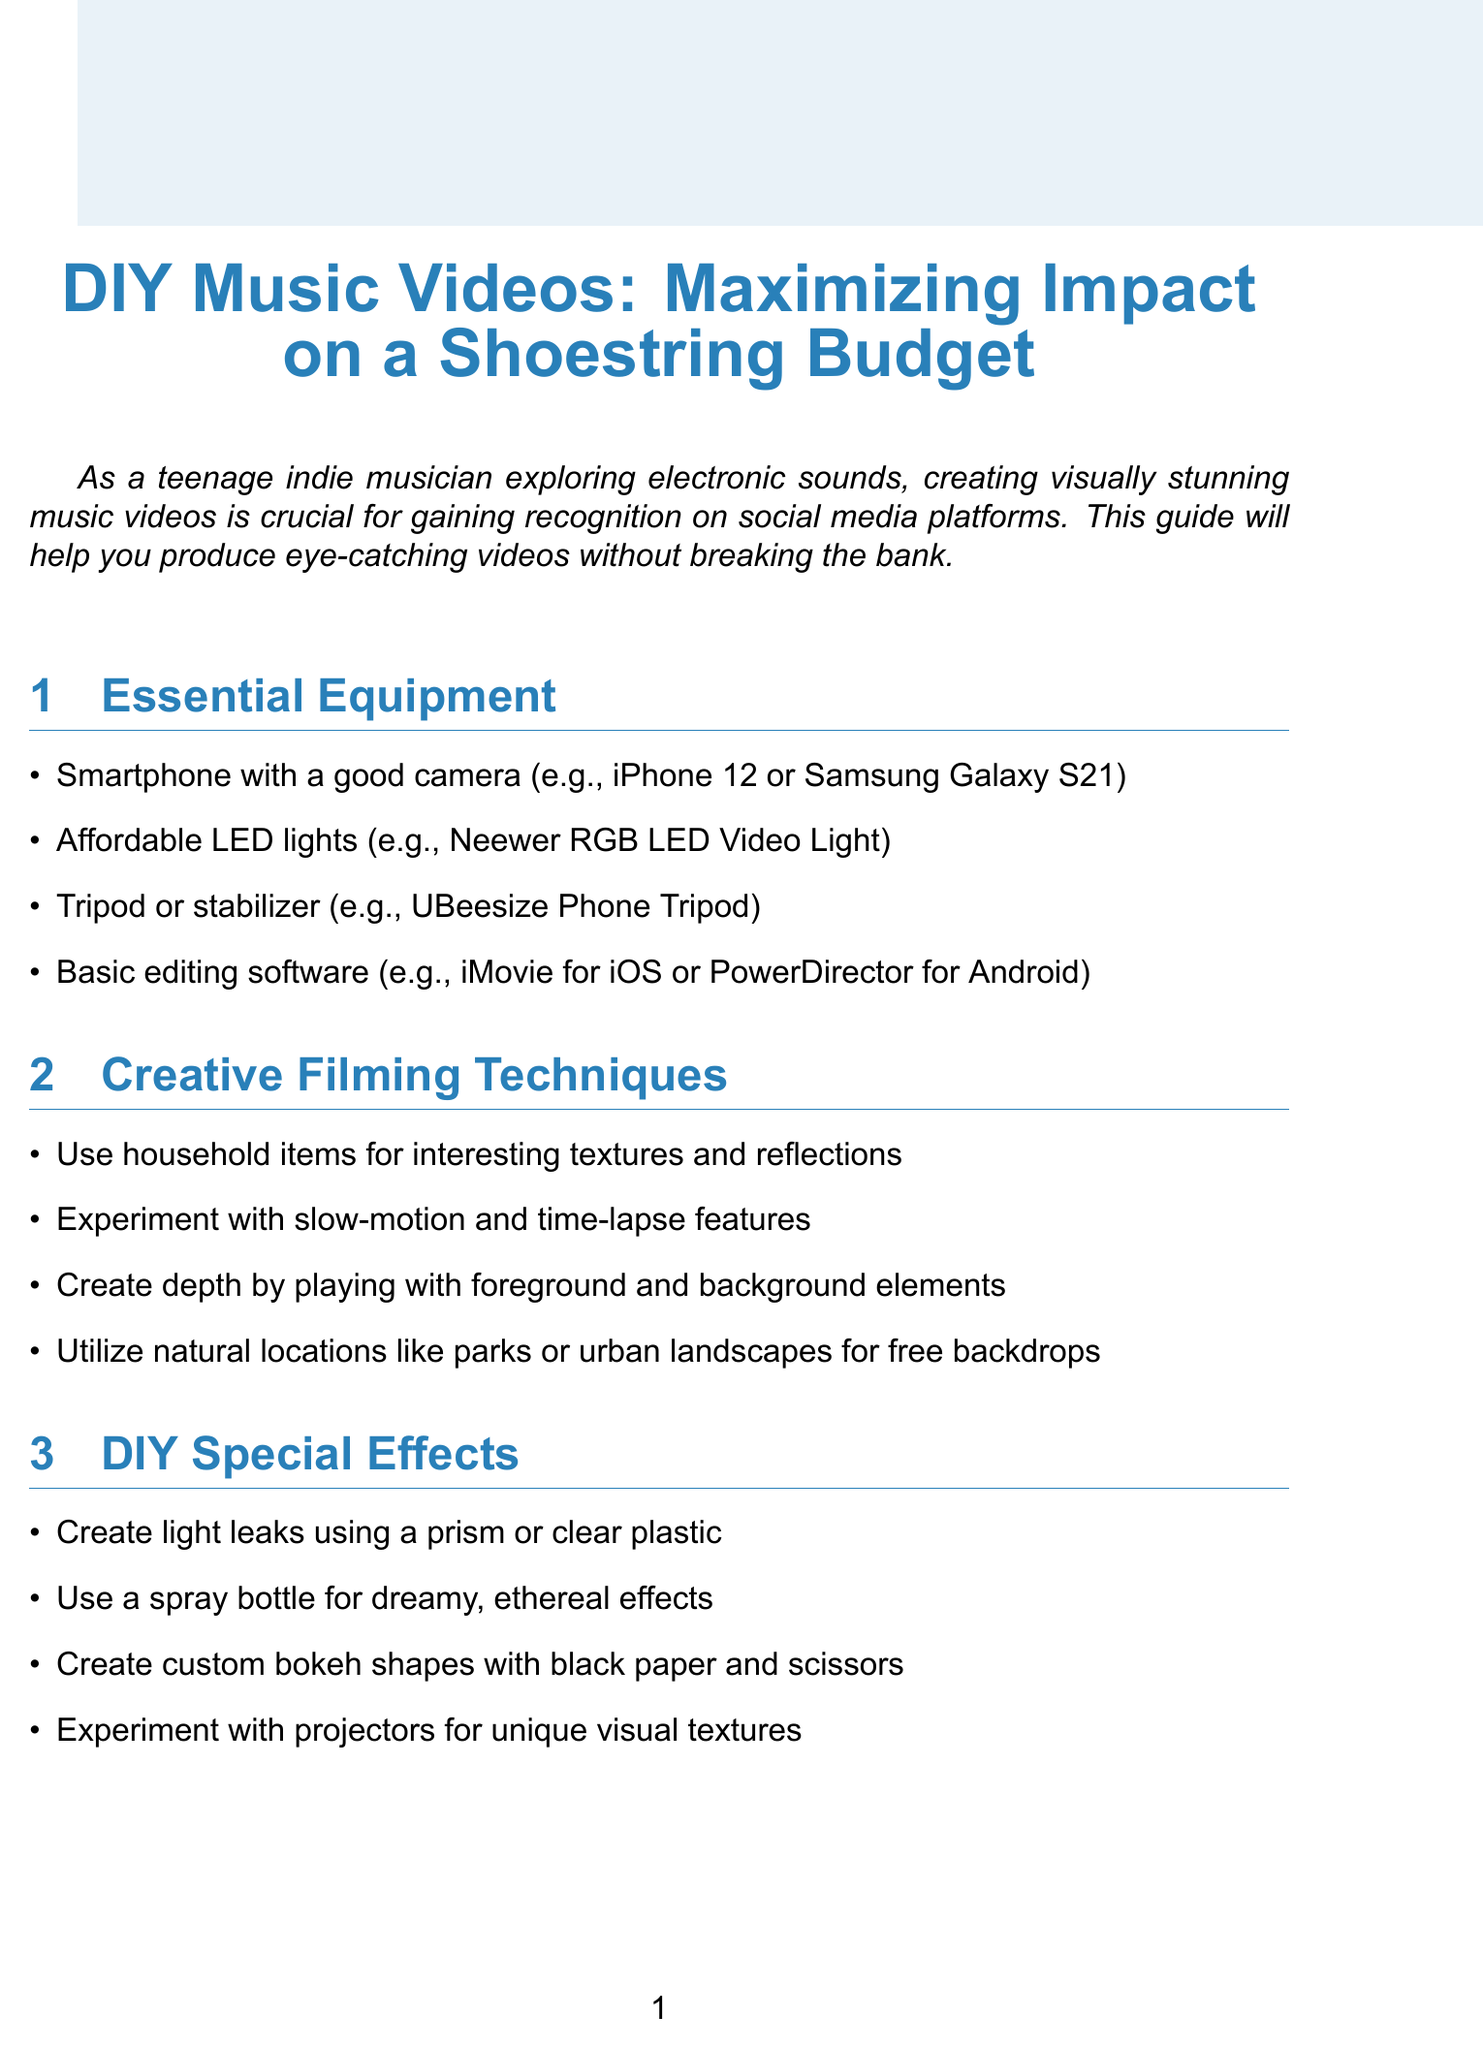What is the title of the newsletter? The title is provided at the beginning of the document and is "DIY Music Videos: Maximizing Impact on a Shoestring Budget."
Answer: DIY Music Videos: Maximizing Impact on a Shoestring Budget What is one recommended camera for filming? The document lists specific examples of smartphones with good cameras, one of which is the iPhone 12.
Answer: iPhone 12 What creative technique involves using household items? The content mentions using household items for interesting textures and reflections as a creative filming technique.
Answer: Textures and reflections What is a suggested software for editing? The document states "iMovie for iOS" as an example of basic editing software suitable for the budget.
Answer: iMovie What is the maximum recommended video length for better engagement? The newsletter suggests keeping videos under 60 seconds for better engagement on social media platforms.
Answer: 60 seconds Which artist's videos should you study for unique angles? The document mentions studying Billie Eilish's homemade videos for unique angles and lighting.
Answer: Billie Eilish What DIY special effect can be created using a prism? A prism can be used to create light leaks as mentioned in the DIY special effects section.
Answer: Light leaks What type of versions should be created for Instagram Reels? The document specifically mentions creating vertical versions for Instagram Reels and TikTok.
Answer: Vertical versions What trend is recommended for hashtags? The newsletter suggests using trending hashtags such as #indiemusic and #electronicmusic.
Answer: #indiemusic and #electronicmusic 